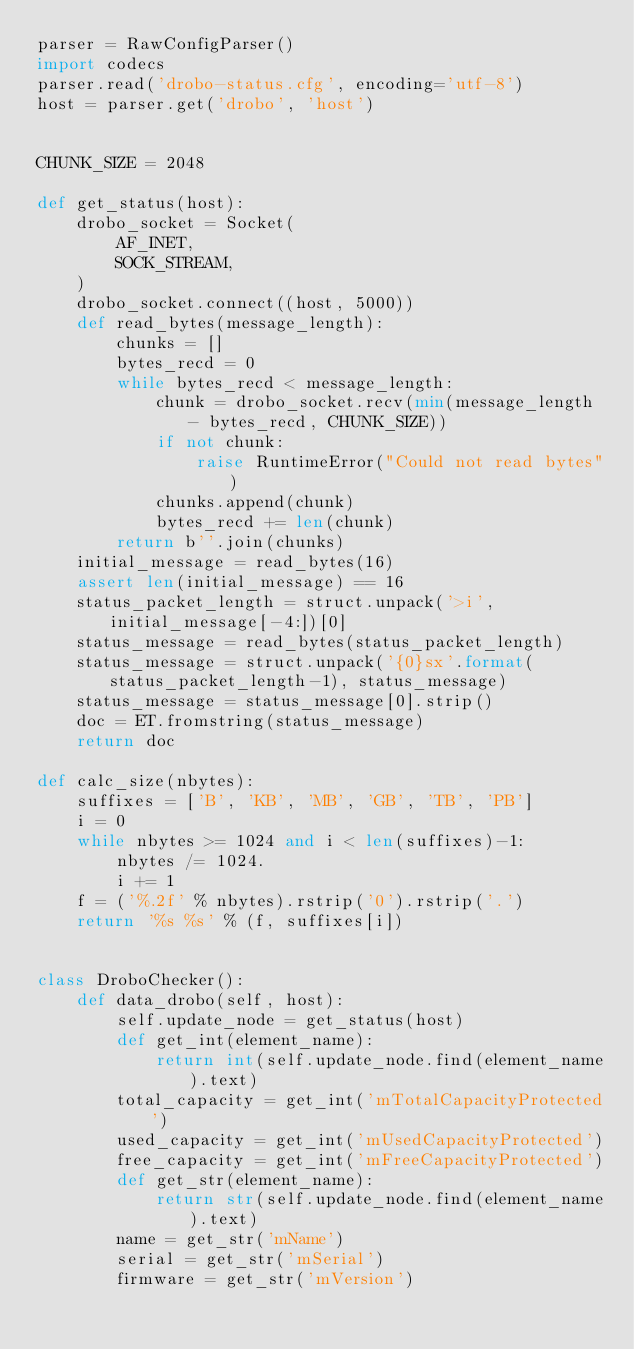Convert code to text. <code><loc_0><loc_0><loc_500><loc_500><_Python_>parser = RawConfigParser()
import codecs
parser.read('drobo-status.cfg', encoding='utf-8')
host = parser.get('drobo', 'host')


CHUNK_SIZE = 2048

def get_status(host):
    drobo_socket = Socket(
        AF_INET,
        SOCK_STREAM,
    )
    drobo_socket.connect((host, 5000))
    def read_bytes(message_length):
        chunks = []
        bytes_recd = 0
        while bytes_recd < message_length:
            chunk = drobo_socket.recv(min(message_length - bytes_recd, CHUNK_SIZE))
            if not chunk:
                raise RuntimeError("Could not read bytes")
            chunks.append(chunk)
            bytes_recd += len(chunk)
        return b''.join(chunks)
    initial_message = read_bytes(16)
    assert len(initial_message) == 16
    status_packet_length = struct.unpack('>i', initial_message[-4:])[0]
    status_message = read_bytes(status_packet_length)
    status_message = struct.unpack('{0}sx'.format(status_packet_length-1), status_message)
    status_message = status_message[0].strip()
    doc = ET.fromstring(status_message)
    return doc

def calc_size(nbytes):
    suffixes = ['B', 'KB', 'MB', 'GB', 'TB', 'PB']
    i = 0
    while nbytes >= 1024 and i < len(suffixes)-1:
        nbytes /= 1024.
        i += 1
    f = ('%.2f' % nbytes).rstrip('0').rstrip('.')
    return '%s %s' % (f, suffixes[i])


class DroboChecker():
    def data_drobo(self, host):
        self.update_node = get_status(host)
        def get_int(element_name):
            return int(self.update_node.find(element_name).text)
        total_capacity = get_int('mTotalCapacityProtected')
        used_capacity = get_int('mUsedCapacityProtected')
        free_capacity = get_int('mFreeCapacityProtected')
        def get_str(element_name):
            return str(self.update_node.find(element_name).text)
        name = get_str('mName')
        serial = get_str('mSerial')
        firmware = get_str('mVersion')</code> 